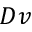<formula> <loc_0><loc_0><loc_500><loc_500>D v</formula> 